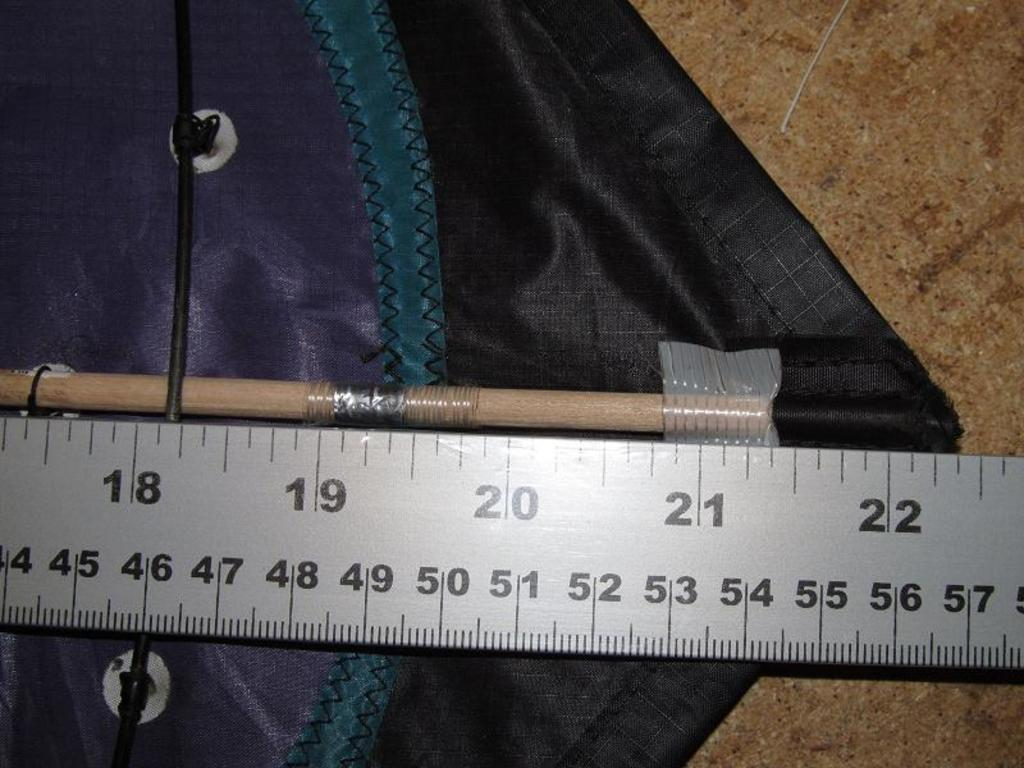Provide a one-sentence caption for the provided image. A rod inserted into a pocket of polyester blend fabric with a ruler measuring 22 and 3 eigths inches. 